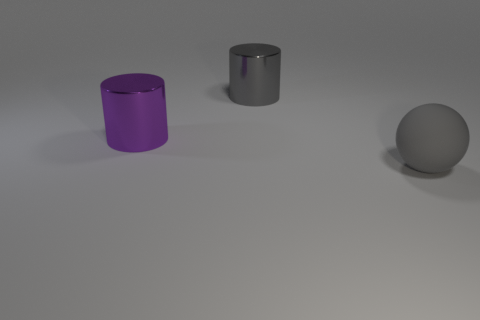What materials do the objects in the image seem to be made of? The cylinders appear to have a metallic finish, with the larger one having a purple tint, indicating it might be made of painted or anodized metal. The sphere has a matte finish and could be made of a material like plastic or rubber. 